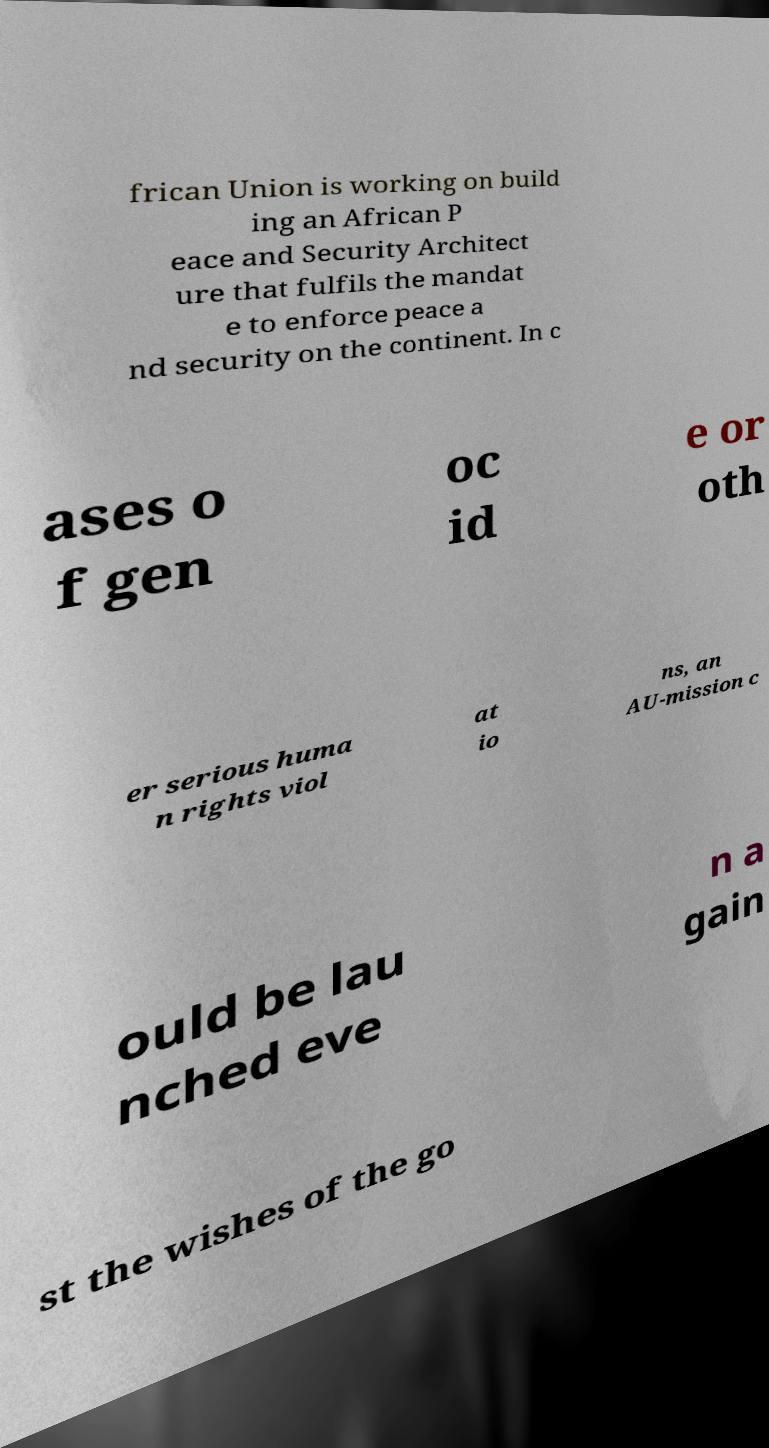Can you accurately transcribe the text from the provided image for me? frican Union is working on build ing an African P eace and Security Architect ure that fulfils the mandat e to enforce peace a nd security on the continent. In c ases o f gen oc id e or oth er serious huma n rights viol at io ns, an AU-mission c ould be lau nched eve n a gain st the wishes of the go 